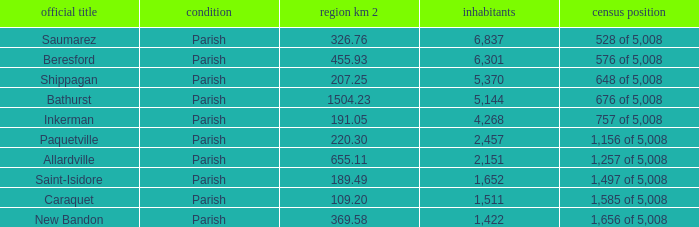What is the Area of the Saint-Isidore Parish with a Population smaller than 4,268? 189.49. 